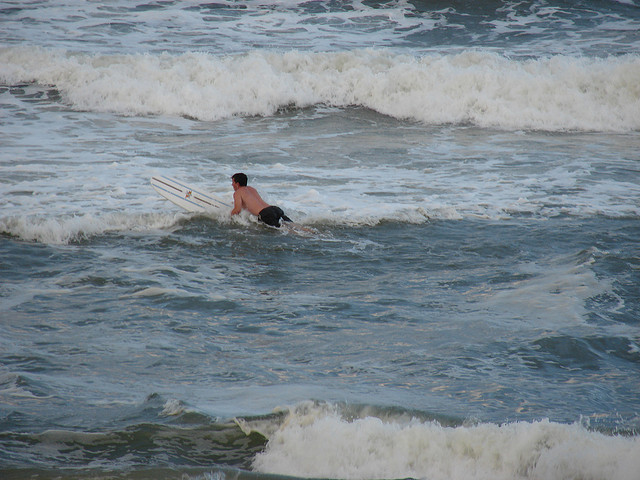<image>Is this at the beach? I am not sure if this is at the beach as it is not clearly stated. Is this at the beach? I don't know if this is at the beach. It can be both at the beach or not. 